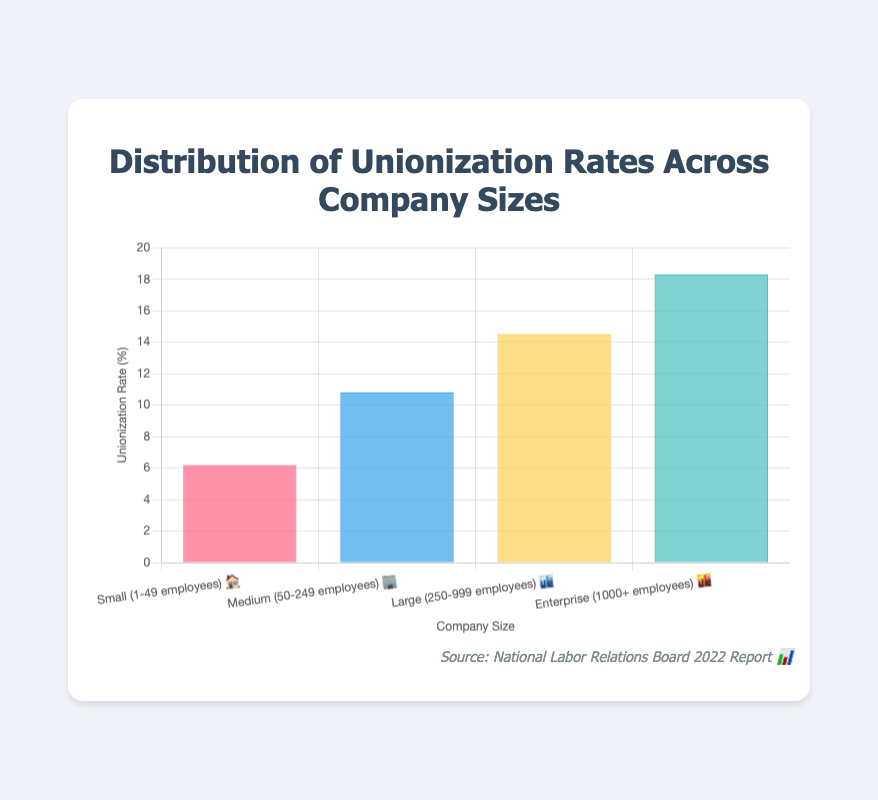What is the title of the chart? The title is displayed at the top center of the chart, reading "Distribution of Unionization Rates Across Company Sizes"
Answer: Distribution of Unionization Rates Across Company Sizes Which company size has the highest unionization rate? Looking at the height of the bars in the chart, the tallest bar corresponds to "Enterprise (1000+ employees) 🌆", indicating the highest unionization rate.
Answer: Enterprise (1000+ employees) 🌆 How does the unionization rate change as company size increases? Observing the trend from the smallest to the largest company sizes, the heights of the bars increase progressively, indicating higher unionization rates with larger company sizes.
Answer: Unionization rate increases with company size What is the unionization rate for medium-sized companies? By looking at the bar labeled "Medium (50-249 employees) 🏢", the unionization rate is observed at the top of that bar, which is 10.8%.
Answer: 10.8% What is the difference in unionization rates between the largest and smallest company sizes? The unionization rate for "Enterprise (1000+ employees) 🌆" is 18.3%, and for "Small (1-49 employees) 🏠" it is 6.2%. Subtracting these gives 18.3% - 6.2% = 12.1%.
Answer: 12.1% Which company size category sees a significant increase in unionization rate compared to the previous category? Comparing the unionization rates moving from one category to the next, the jump from "Small (1-49 employees) 🏠" at 6.2% to "Medium (50-249 employees) 🏢" at 10.8% shows a significant increase of 4.6%.
Answer: From Small (1-49 employees) 🏠 to Medium (50-249 employees) 🏢 What is the average unionization rate across all company sizes? Adding up all the unionization rates (6.2% + 10.8% + 14.5% + 18.3%) and dividing by the number of categories (4) gives (6.2 + 10.8 + 14.5 + 18.3) / 4 = 12.45%.
Answer: 12.45% How many company size categories are there in the chart? Counting the number of distinct labels on the x-axis provides the answer, which includes "Small (1-49 employees) 🏠", "Medium (50-249 employees) 🏢", "Large (250-999 employees) 🏙️", and "Enterprise (1000+ employees) 🌆".
Answer: 4 Is the unionization rate for large companies closer to that of medium or enterprise companies? The unionization rate for "Large (250-999 employees) 🏙️" is 14.5%. Comparing it to "Medium (50-249 employees) 🏢" at 10.8% and "Enterprise (1000+ employees) 🌆" at 18.3%, it is closer to 18.3%.
Answer: Closer to enterprise companies What color is used to represent the unionization rate for small companies? The bar representing "Small (1-49 employees) 🏠" is colored in a shade of red.
Answer: Red 